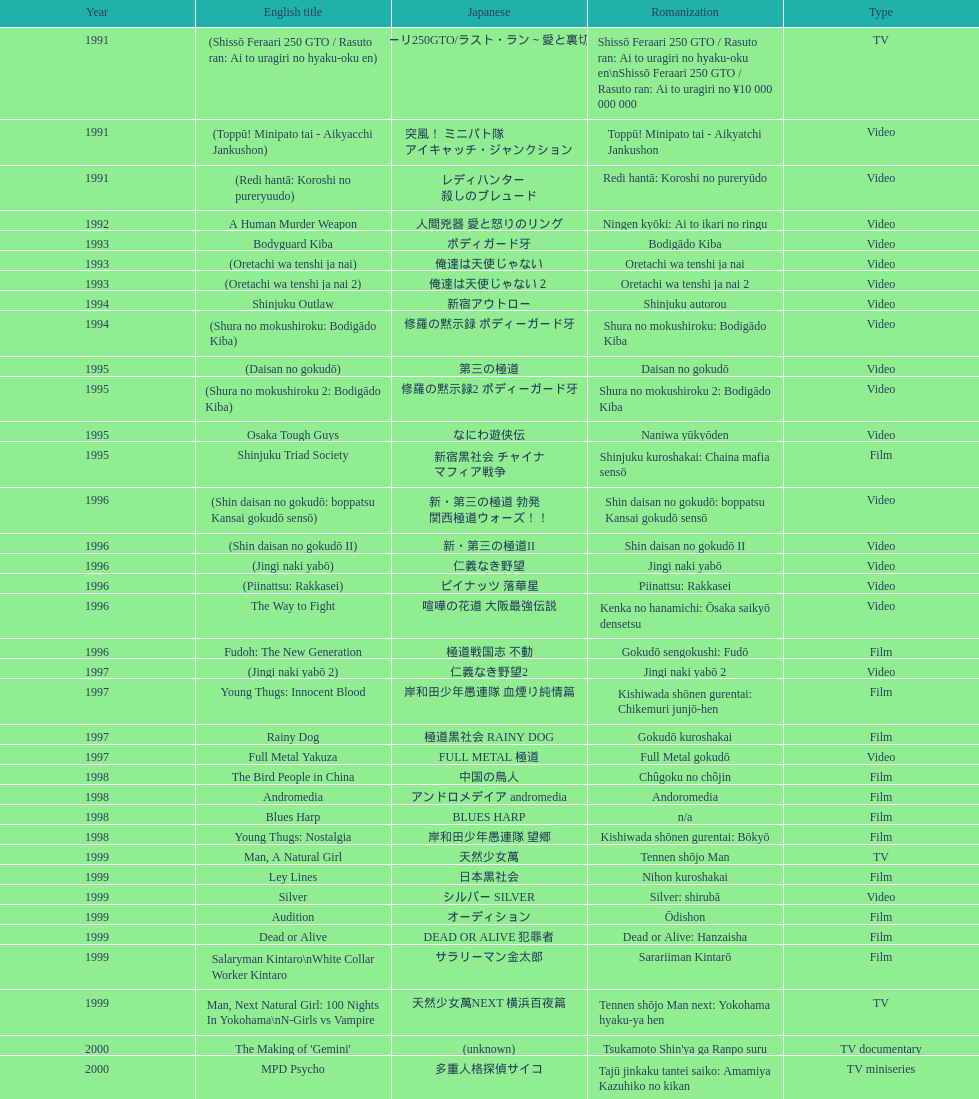Which title comes following "the way to fight"? Fudoh: The New Generation. 